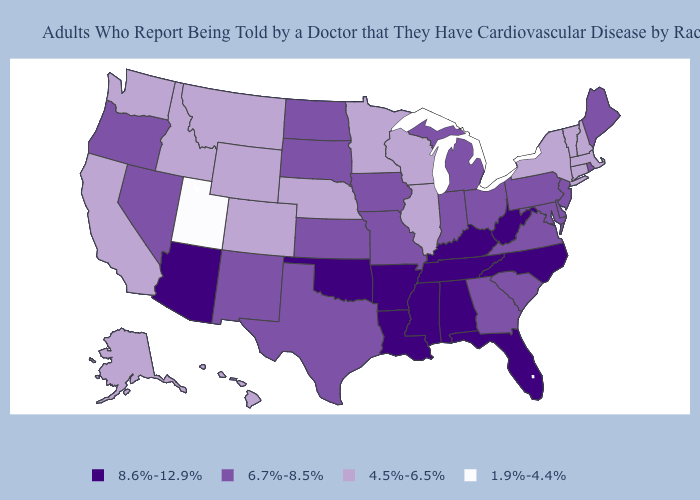What is the value of Wisconsin?
Quick response, please. 4.5%-6.5%. Among the states that border South Dakota , which have the lowest value?
Answer briefly. Minnesota, Montana, Nebraska, Wyoming. Name the states that have a value in the range 8.6%-12.9%?
Concise answer only. Alabama, Arizona, Arkansas, Florida, Kentucky, Louisiana, Mississippi, North Carolina, Oklahoma, Tennessee, West Virginia. Name the states that have a value in the range 8.6%-12.9%?
Keep it brief. Alabama, Arizona, Arkansas, Florida, Kentucky, Louisiana, Mississippi, North Carolina, Oklahoma, Tennessee, West Virginia. Name the states that have a value in the range 4.5%-6.5%?
Answer briefly. Alaska, California, Colorado, Connecticut, Hawaii, Idaho, Illinois, Massachusetts, Minnesota, Montana, Nebraska, New Hampshire, New York, Vermont, Washington, Wisconsin, Wyoming. Is the legend a continuous bar?
Be succinct. No. Does South Dakota have the same value as Idaho?
Short answer required. No. What is the highest value in the USA?
Concise answer only. 8.6%-12.9%. Does Virginia have the highest value in the South?
Keep it brief. No. Does South Carolina have the lowest value in the South?
Concise answer only. Yes. Name the states that have a value in the range 6.7%-8.5%?
Keep it brief. Delaware, Georgia, Indiana, Iowa, Kansas, Maine, Maryland, Michigan, Missouri, Nevada, New Jersey, New Mexico, North Dakota, Ohio, Oregon, Pennsylvania, Rhode Island, South Carolina, South Dakota, Texas, Virginia. What is the highest value in the MidWest ?
Short answer required. 6.7%-8.5%. Which states have the lowest value in the MidWest?
Short answer required. Illinois, Minnesota, Nebraska, Wisconsin. Name the states that have a value in the range 8.6%-12.9%?
Keep it brief. Alabama, Arizona, Arkansas, Florida, Kentucky, Louisiana, Mississippi, North Carolina, Oklahoma, Tennessee, West Virginia. Does Alaska have the highest value in the West?
Short answer required. No. 